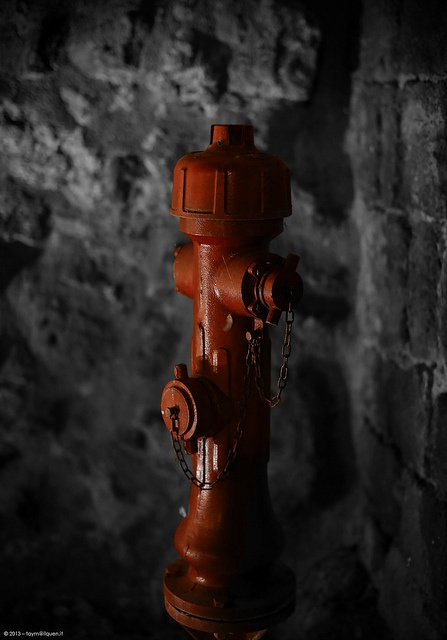Describe the objects in this image and their specific colors. I can see a fire hydrant in black, maroon, and brown tones in this image. 